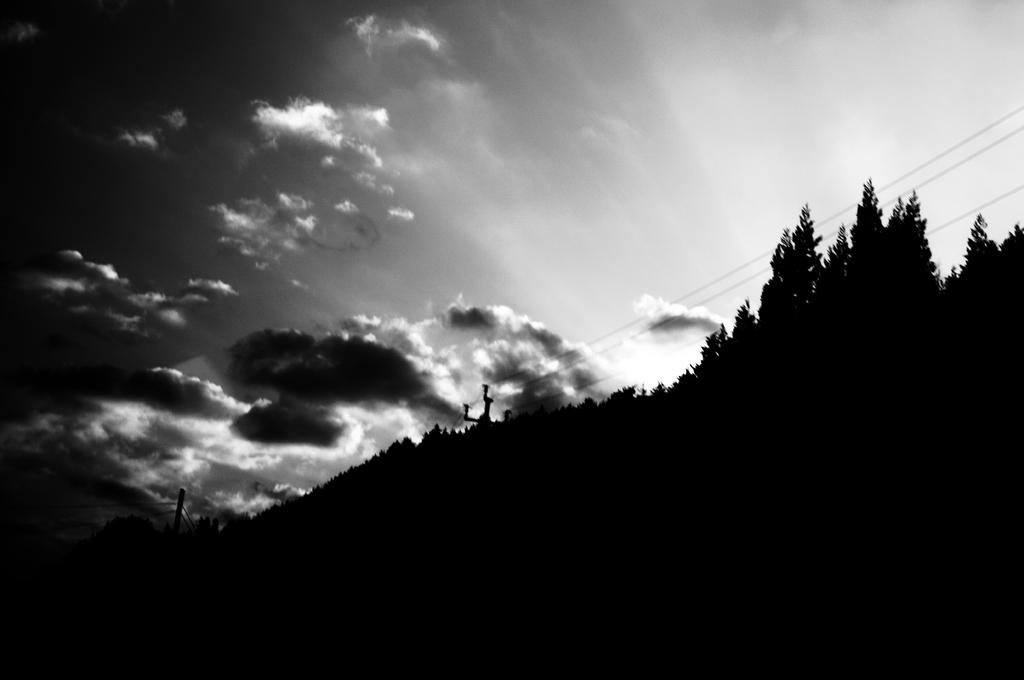What is the color scheme of the image? The image is black and white. What can be seen in the sky in the image? There are clouds in the sky in the image. What type of vegetation is present in the image? There are trees in the image. What else can be seen in the image besides the sky and trees? There are wires in the image. Where is the jail located in the image? There is no jail present in the image. Can you see any cobwebs hanging from the trees in the image? There is no mention of cobwebs in the image, and they are not visible in the provided facts. 